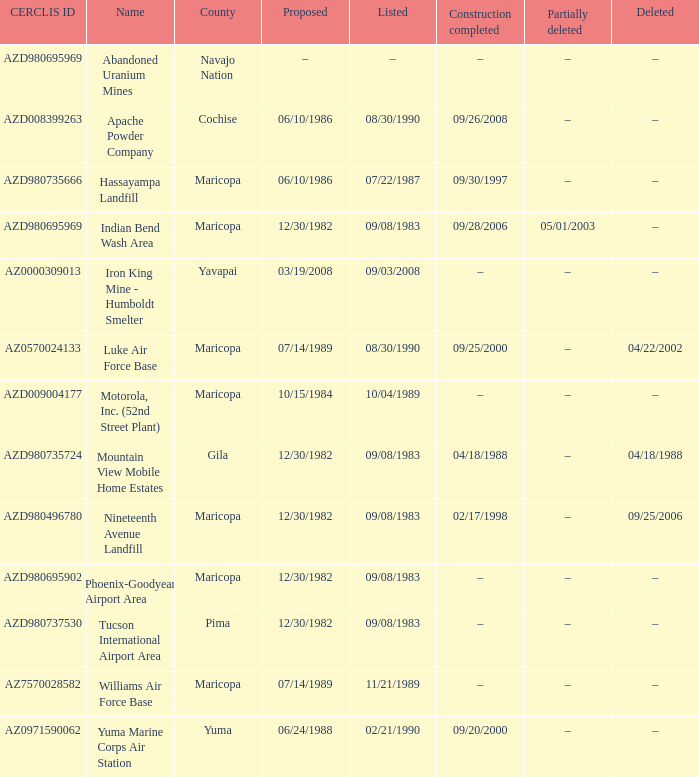When was the site partially deleted when the cerclis id is az7570028582? –. Would you be able to parse every entry in this table? {'header': ['CERCLIS ID', 'Name', 'County', 'Proposed', 'Listed', 'Construction completed', 'Partially deleted', 'Deleted'], 'rows': [['AZD980695969', 'Abandoned Uranium Mines', 'Navajo Nation', '–', '–', '–', '–', '–'], ['AZD008399263', 'Apache Powder Company', 'Cochise', '06/10/1986', '08/30/1990', '09/26/2008', '–', '–'], ['AZD980735666', 'Hassayampa Landfill', 'Maricopa', '06/10/1986', '07/22/1987', '09/30/1997', '–', '–'], ['AZD980695969', 'Indian Bend Wash Area', 'Maricopa', '12/30/1982', '09/08/1983', '09/28/2006', '05/01/2003', '–'], ['AZ0000309013', 'Iron King Mine - Humboldt Smelter', 'Yavapai', '03/19/2008', '09/03/2008', '–', '–', '–'], ['AZ0570024133', 'Luke Air Force Base', 'Maricopa', '07/14/1989', '08/30/1990', '09/25/2000', '–', '04/22/2002'], ['AZD009004177', 'Motorola, Inc. (52nd Street Plant)', 'Maricopa', '10/15/1984', '10/04/1989', '–', '–', '–'], ['AZD980735724', 'Mountain View Mobile Home Estates', 'Gila', '12/30/1982', '09/08/1983', '04/18/1988', '–', '04/18/1988'], ['AZD980496780', 'Nineteenth Avenue Landfill', 'Maricopa', '12/30/1982', '09/08/1983', '02/17/1998', '–', '09/25/2006'], ['AZD980695902', 'Phoenix-Goodyear Airport Area', 'Maricopa', '12/30/1982', '09/08/1983', '–', '–', '–'], ['AZD980737530', 'Tucson International Airport Area', 'Pima', '12/30/1982', '09/08/1983', '–', '–', '–'], ['AZ7570028582', 'Williams Air Force Base', 'Maricopa', '07/14/1989', '11/21/1989', '–', '–', '–'], ['AZ0971590062', 'Yuma Marine Corps Air Station', 'Yuma', '06/24/1988', '02/21/1990', '09/20/2000', '–', '–']]} 